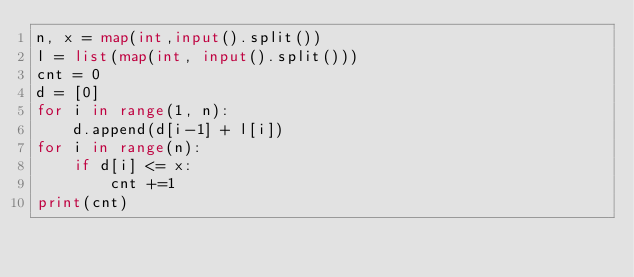Convert code to text. <code><loc_0><loc_0><loc_500><loc_500><_Python_>n, x = map(int,input().split())
l = list(map(int, input().split()))
cnt = 0
d = [0]
for i in range(1, n):
    d.append(d[i-1] + l[i])
for i in range(n):
    if d[i] <= x:
        cnt +=1
print(cnt)</code> 